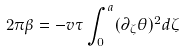Convert formula to latex. <formula><loc_0><loc_0><loc_500><loc_500>2 \pi \beta = - v \tau \int _ { 0 } ^ { a } ( \partial _ { \zeta } \theta ) ^ { 2 } d \zeta</formula> 